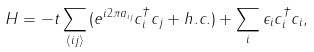<formula> <loc_0><loc_0><loc_500><loc_500>H = - t \sum _ { \langle i j \rangle } { ( e ^ { i 2 \pi a _ { i j } } c ^ { \dagger } _ { i } c _ { j } + h . c . ) } + \sum _ { i } { \epsilon _ { i } c ^ { \dagger } _ { i } c _ { i } } ,</formula> 